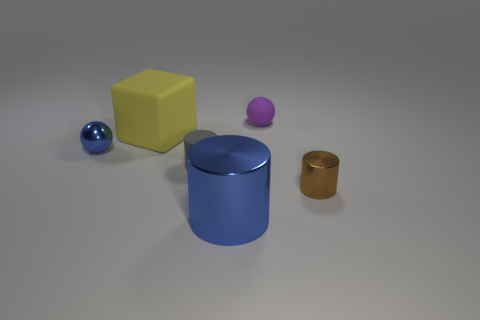Add 3 gray cylinders. How many objects exist? 9 Add 3 small purple objects. How many small purple objects are left? 4 Add 5 rubber blocks. How many rubber blocks exist? 6 Subtract 0 red cylinders. How many objects are left? 6 Subtract all blocks. How many objects are left? 5 Subtract all big green matte blocks. Subtract all tiny purple rubber balls. How many objects are left? 5 